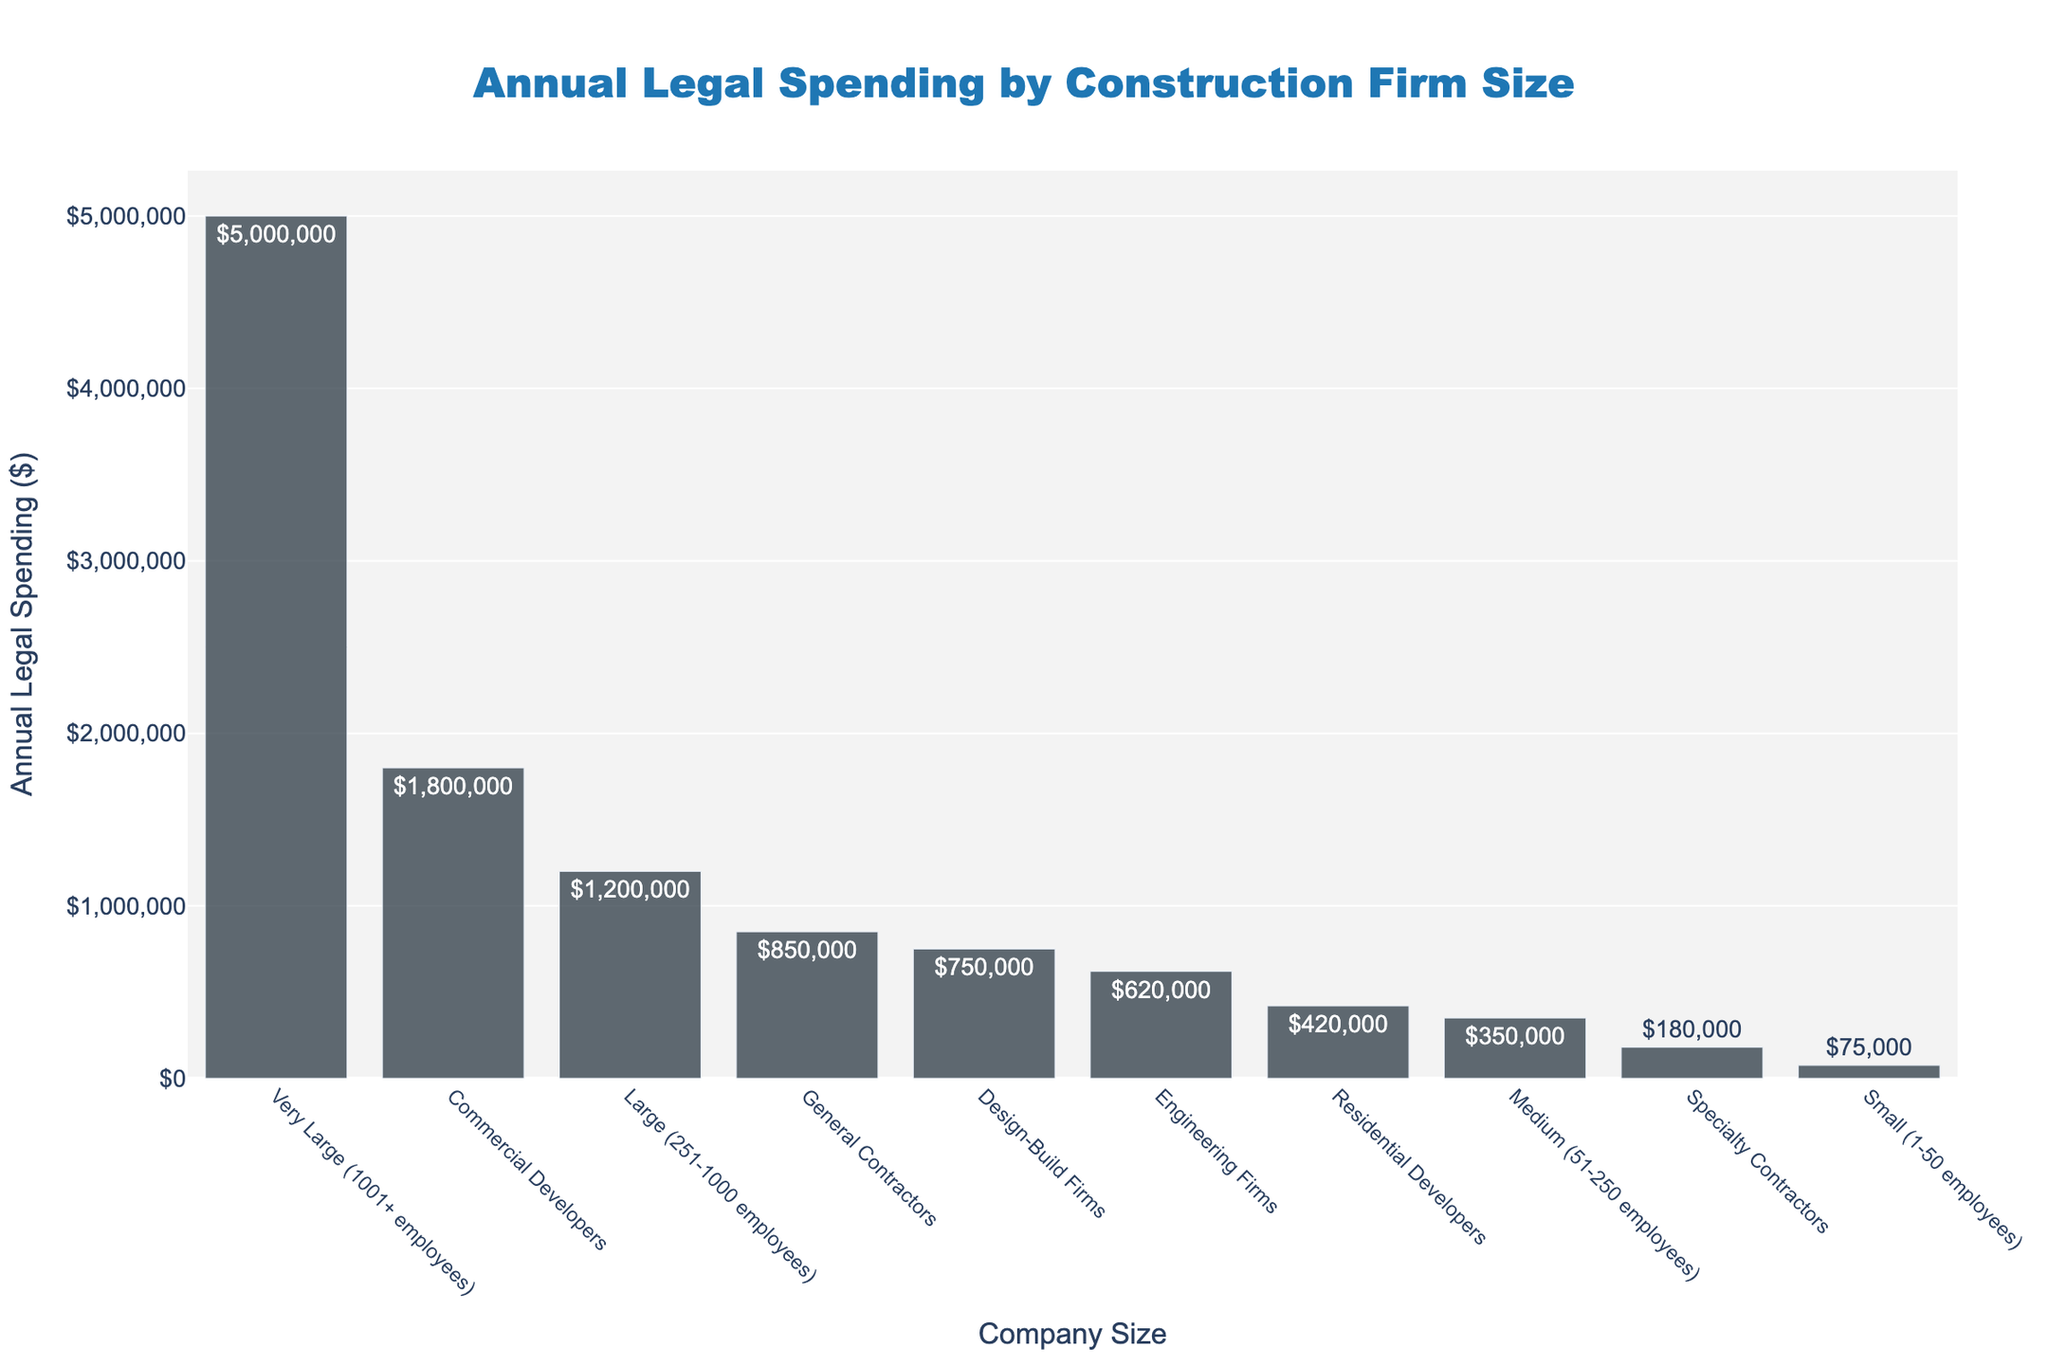Which company size has the highest total annual legal spending? By visually inspecting the bar chart, the very largest bar represents the "Very Large (1001+ employees)" companies, showing the highest annual legal spending.
Answer: "Very Large (1001+ employees)" Which company size spends the least annually on legal services? By looking for the shortest bar in the graph, it is for "Specialty Contractors", indicating the lowest annual spending.
Answer: "Specialty Contractors" How much more do "Commercial Developers" spend annually on legal services compared to "Medium (51-250 employees)" companies? The bars show that "Commercial Developers" spend $1,800,000 and "Medium (51-250 employees)" companies spend $350,000. Subtracting these amounts gives $1,800,000 - $350,000 = $1,450,000.
Answer: $1,450,000 What is the combined annual legal spending for "General Contractors" and "Design-Build Firms"? Locate the bars for "General Contractors" ($850,000) and "Design-Build Firms" ($750,000), then sum these values: $850,000 + $750,000 = $1,600,000.
Answer: $1,600,000 Which company size spends nearly twice as much on legal services as "Residential Developers"? "Residential Developers" spend $420,000. Looking for a bar that's nearly twice this amount (~$840,000), "General Contractors" with $850,000 fits closely.
Answer: "General Contractors" What is the difference in annual legal spending between "Engineering Firms" and "Specialty Contractors"? The bar chart shows "Engineering Firms" spend $620,000 and "Specialty Contractors" spend $180,000. The difference is $620,000 - $180,000 = $440,000.
Answer: $440,000 How does the annual legal spending of "Large (251-1000 employees)" compare to "General Contractors"? The bars show "Large (251-1000 employees)" spend $1,200,000 and "General Contractors" spend $850,000. "Large (251-1000 employees)" spend more.
Answer: "Large (251-1000 employees)" What is the average annual legal spending of small and very large companies? The bars show annual spending of "Small (1-50 employees)" is $75,000 and "Very Large (1001+ employees)" is $5,000,000. The average is calculated as: ($75,000 + $5,000,000) / 2 = $2,537,500.
Answer: $2,537,500 Between "Design-Build Firms" and "Residential Developers", which company size spends more on annual legal services? The bars show "Design-Build Firms" spend $750,000 and "Residential Developers" spend $420,000. "Design-Build Firms" spend more.
Answer: "Design-Build Firms" 